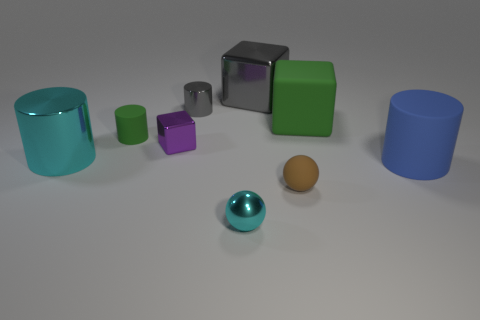Subtract all small metal cylinders. How many cylinders are left? 3 Subtract all blue cylinders. How many cylinders are left? 3 Subtract 2 cylinders. How many cylinders are left? 2 Subtract all purple balls. How many blue cylinders are left? 1 Add 1 gray blocks. How many objects exist? 10 Subtract all spheres. How many objects are left? 7 Subtract all yellow balls. Subtract all red cubes. How many balls are left? 2 Add 8 small purple metal blocks. How many small purple metal blocks are left? 9 Add 5 tiny green shiny things. How many tiny green shiny things exist? 5 Subtract 1 green blocks. How many objects are left? 8 